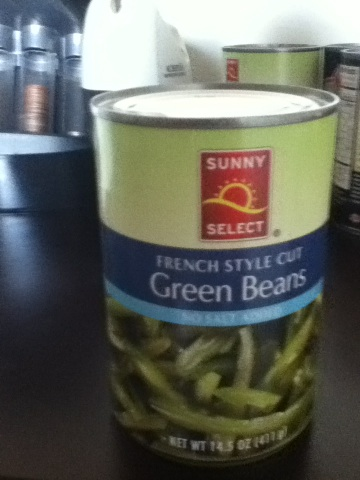How would you suggest serving these green beans? French Style Cut Green Beans can be served in a variety of ways. They can be simply heated and seasoned with butter, salt, and pepper, or mixed into a casserole recipe. They are also great stirred into pastas or salads for added texture and nutrition. 